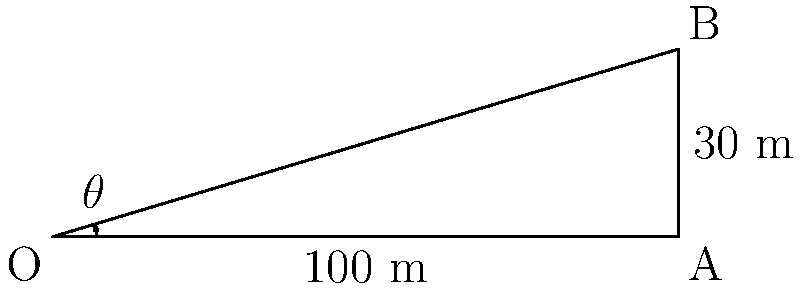A medieval siege engineer is planning to use a trebuchet to launch a projectile at an enemy fortress. The target is 100 meters away and 30 meters above the trebuchet's base. What angle of elevation (θ) should the engineer set for the trebuchet to hit the target accurately? Round your answer to the nearest degree. To solve this problem, we'll use trigonometry:

1. We have a right triangle with the following information:
   - Adjacent side (horizontal distance) = 100 m
   - Opposite side (vertical height) = 30 m
   - We need to find the angle θ

2. The tangent of an angle in a right triangle is the ratio of the opposite side to the adjacent side:

   $$\tan(\theta) = \frac{\text{opposite}}{\text{adjacent}} = \frac{\text{height}}{\text{distance}}$$

3. Substituting our values:

   $$\tan(\theta) = \frac{30}{100} = 0.3$$

4. To find θ, we need to use the inverse tangent (arctangent) function:

   $$\theta = \arctan(0.3)$$

5. Using a calculator or trigonometric tables:

   $$\theta \approx 16.70^\circ$$

6. Rounding to the nearest degree:

   $$\theta \approx 17^\circ$$

Therefore, the siege engineer should set the trebuchet at an angle of elevation of approximately 17 degrees to hit the target accurately.
Answer: 17° 